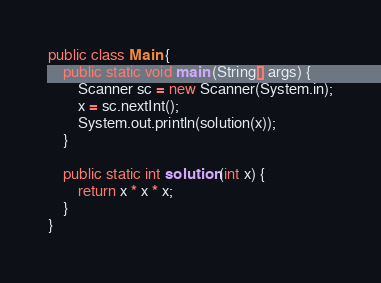<code> <loc_0><loc_0><loc_500><loc_500><_Java_>public class Main {
	public static void main (String[] args) {
		Scanner sc = new Scanner(System.in);
        x = sc.nextInt();
        System.out.println(solution(x));
	}

	public static int solution (int x) {
		return x * x * x;
	}
}
</code> 